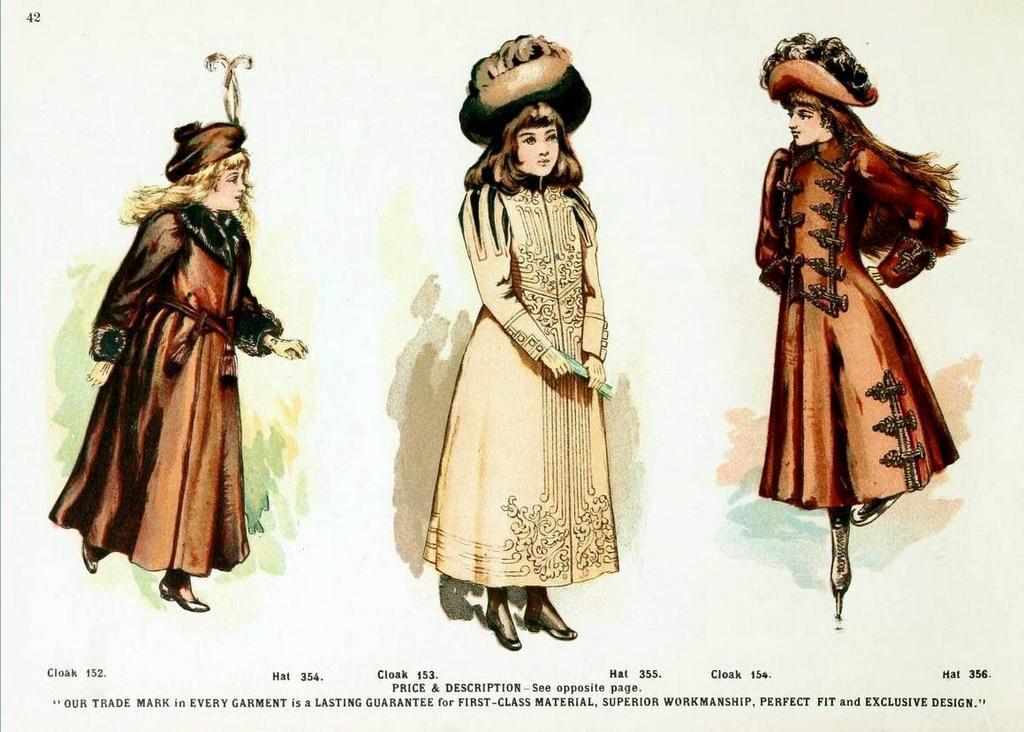Describe this image in one or two sentences. In this image we can see an advertisement. In the advertisement there are women standing on the floor and wearing different costumes. 